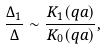Convert formula to latex. <formula><loc_0><loc_0><loc_500><loc_500>\frac { \Delta _ { 1 } } { \Delta } \sim \frac { K _ { 1 } ( q a ) } { K _ { 0 } ( q a ) } ,</formula> 